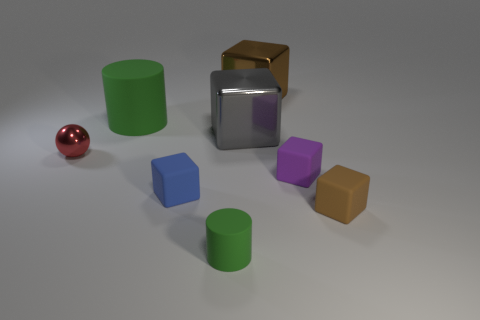There is another cylinder that is the same color as the small rubber cylinder; what is its size?
Offer a terse response. Large. What number of other things are the same size as the purple thing?
Provide a short and direct response. 4. How many cyan matte blocks are there?
Your answer should be very brief. 0. Do the purple matte block and the gray object have the same size?
Make the answer very short. No. How many other objects are there of the same shape as the purple rubber thing?
Make the answer very short. 4. There is a brown thing that is in front of the brown thing that is to the left of the small brown matte thing; what is it made of?
Your answer should be compact. Rubber. Are there any gray blocks on the right side of the purple rubber object?
Your answer should be compact. No. There is a purple matte object; does it have the same size as the metallic cube that is in front of the big brown shiny block?
Your answer should be compact. No. The purple object that is the same shape as the tiny brown object is what size?
Your answer should be compact. Small. Is there any other thing that is the same material as the red ball?
Your answer should be compact. Yes. 